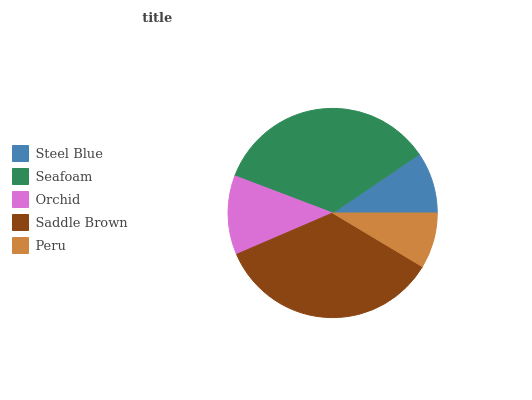Is Peru the minimum?
Answer yes or no. Yes. Is Saddle Brown the maximum?
Answer yes or no. Yes. Is Seafoam the minimum?
Answer yes or no. No. Is Seafoam the maximum?
Answer yes or no. No. Is Seafoam greater than Steel Blue?
Answer yes or no. Yes. Is Steel Blue less than Seafoam?
Answer yes or no. Yes. Is Steel Blue greater than Seafoam?
Answer yes or no. No. Is Seafoam less than Steel Blue?
Answer yes or no. No. Is Orchid the high median?
Answer yes or no. Yes. Is Orchid the low median?
Answer yes or no. Yes. Is Seafoam the high median?
Answer yes or no. No. Is Seafoam the low median?
Answer yes or no. No. 